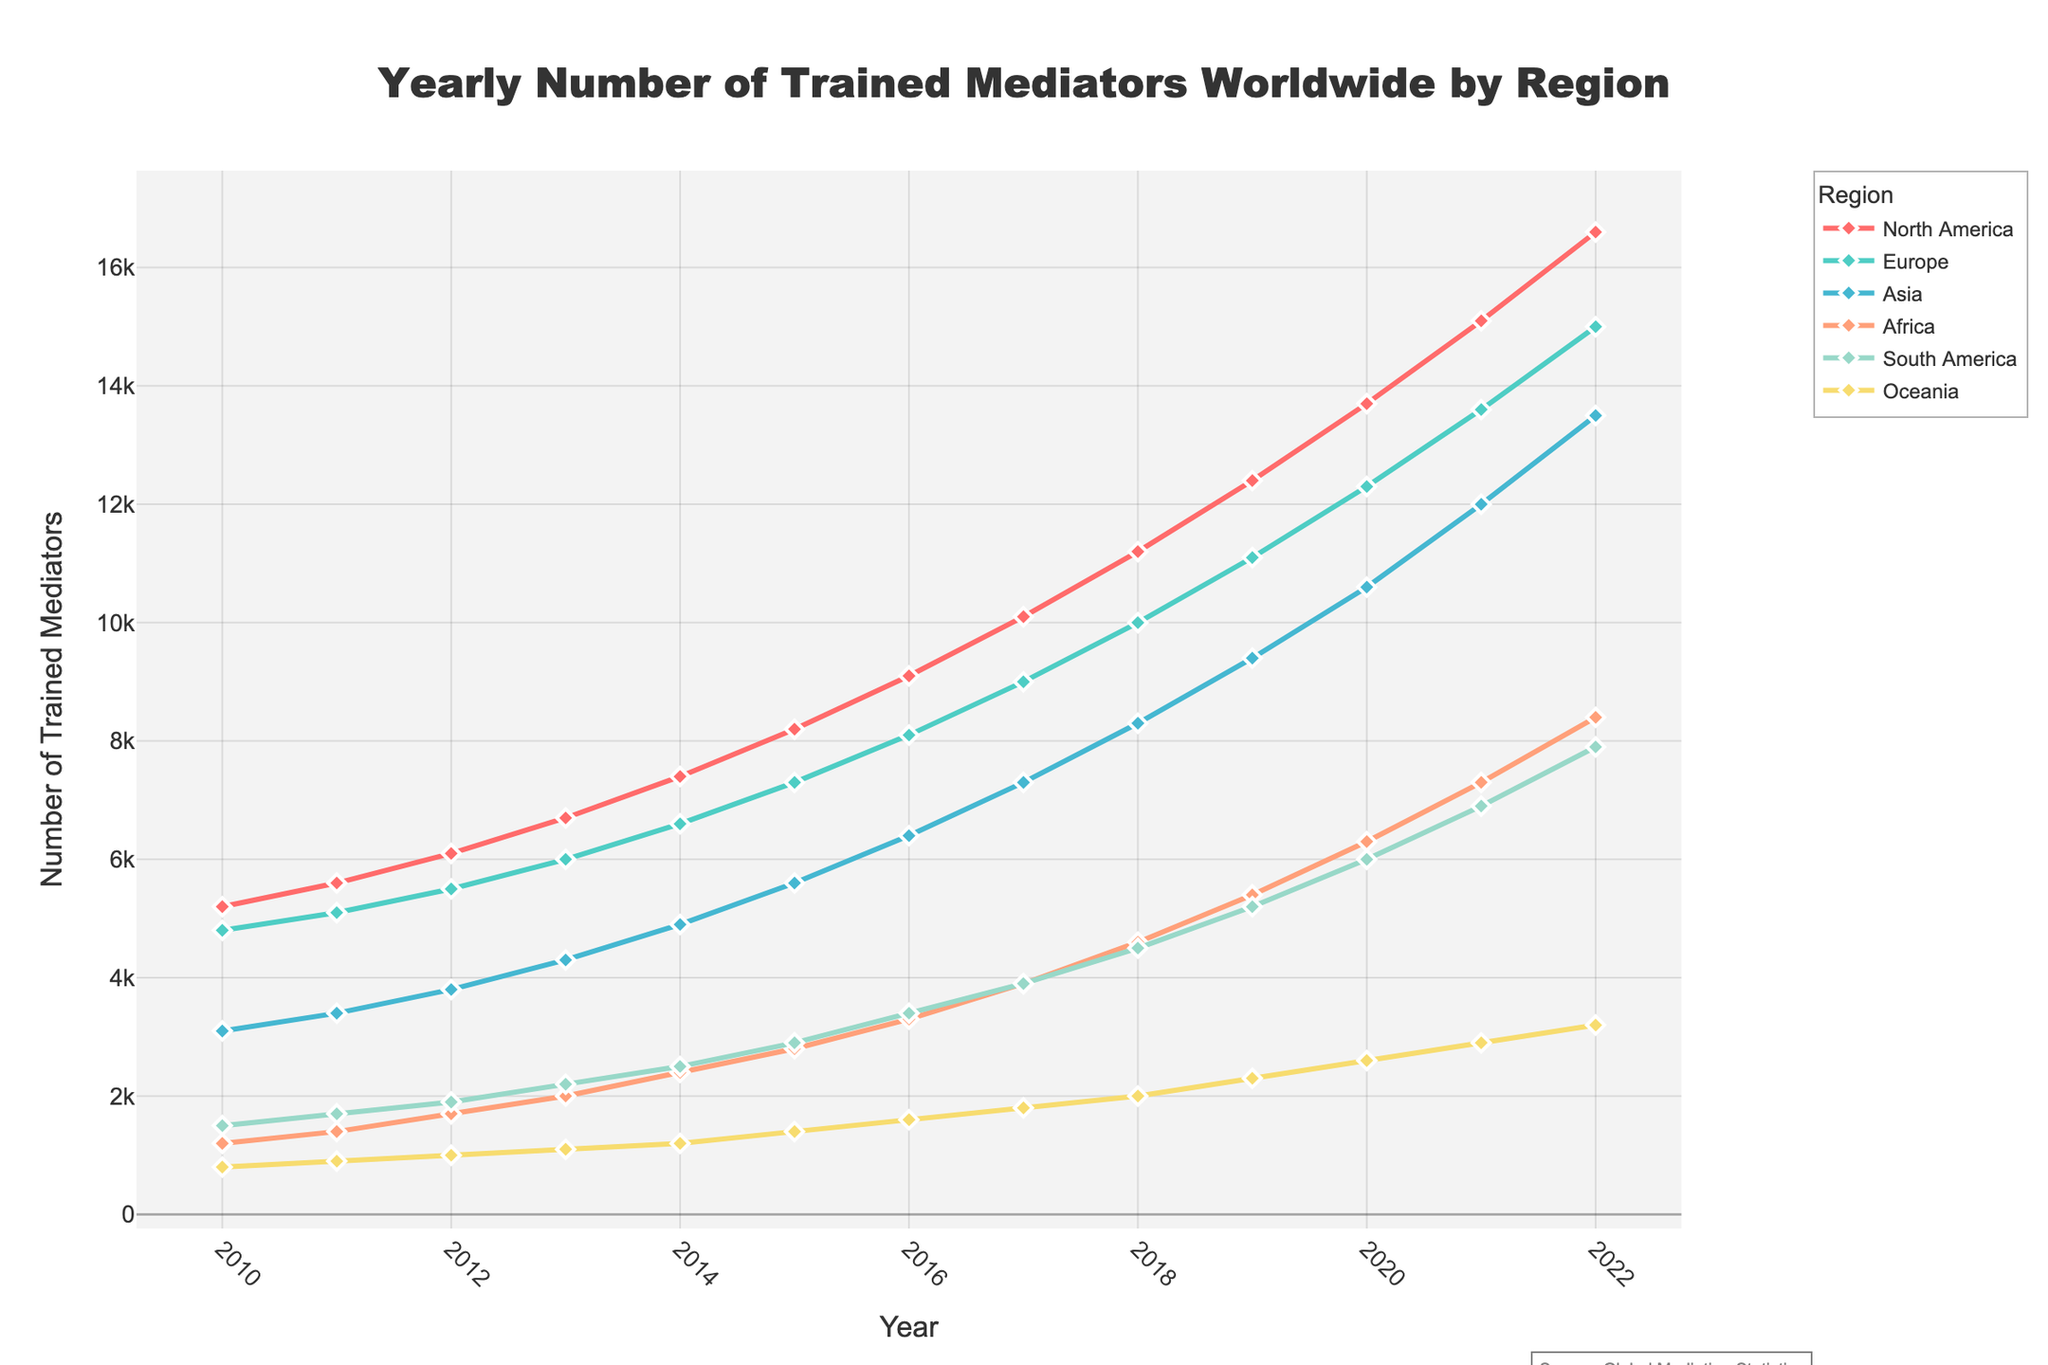What's the trend of the number of trained mediators in North America from 2010 to 2022? The plot shows an upward trend in North America. Starting from 5200 mediators in 2010, the number steadily increases each year, reaching 16600 mediators in 2022.
Answer: Upward Which region had the highest number of trained mediators in 2014? In 2014, North America had the highest number of trained mediators as indicated by the highest point on the plot for that year, with 7400 mediators.
Answer: North America What is the difference in the number of trained mediators between North America and Asia in 2020? In 2020, North America had 13700 trained mediators, and Asia had 10600. The difference is 13700 - 10600 = 3100 mediators.
Answer: 3100 Across all years, which region has consistently shown the lowest numbers of trained mediators? The plot shows Oceania with the lowest number of trained mediators every year compared to other regions, with numbers never exceeding 3200.
Answer: Oceania How does the number of trained mediators in Europe in 2015 compare to those in Asia in 2015? In 2015, Europe had 7300 trained mediators, and Asia had 5600. Thus, Europe had 7300 - 5600 = 1700 more trained mediators than Asia.
Answer: Europe had 1700 more What was the rate of increase in the number of trained mediators in Africa between 2019 and 2021? In 2019, Africa had 5400 mediators, and in 2021, 7300 mediators. The rate of increase is (7300 - 5400) / 5400 * 100% ≈ 35.2%.
Answer: 35.2% What color represents Asia in the figure, and what is its pattern? Asia is represented by a line and markers in green color, and it has diamond-shaped markers.
Answer: Green, diamond markers What is the combined total number of trained mediators in South America and Oceania in 2018? In 2018, South America had 4500 mediators, and Oceania had 2000. The combined total is 4500 + 2000 = 6500 mediators.
Answer: 6500 Which region saw the largest increase in number of trained mediators from 2010 to 2022, and by how many mediators? North America saw the largest increase, from 5200 in 2010 to 16600 in 2022, an increase of 16600 - 5200 = 11400 mediators.
Answer: North America, 11400 mediators Does any region show a decrease in the number of trained mediators in any year within the given period? The plot shows all regions have experienced a continuous increase annually. There is no region with a visible decrease in any year.
Answer: No 